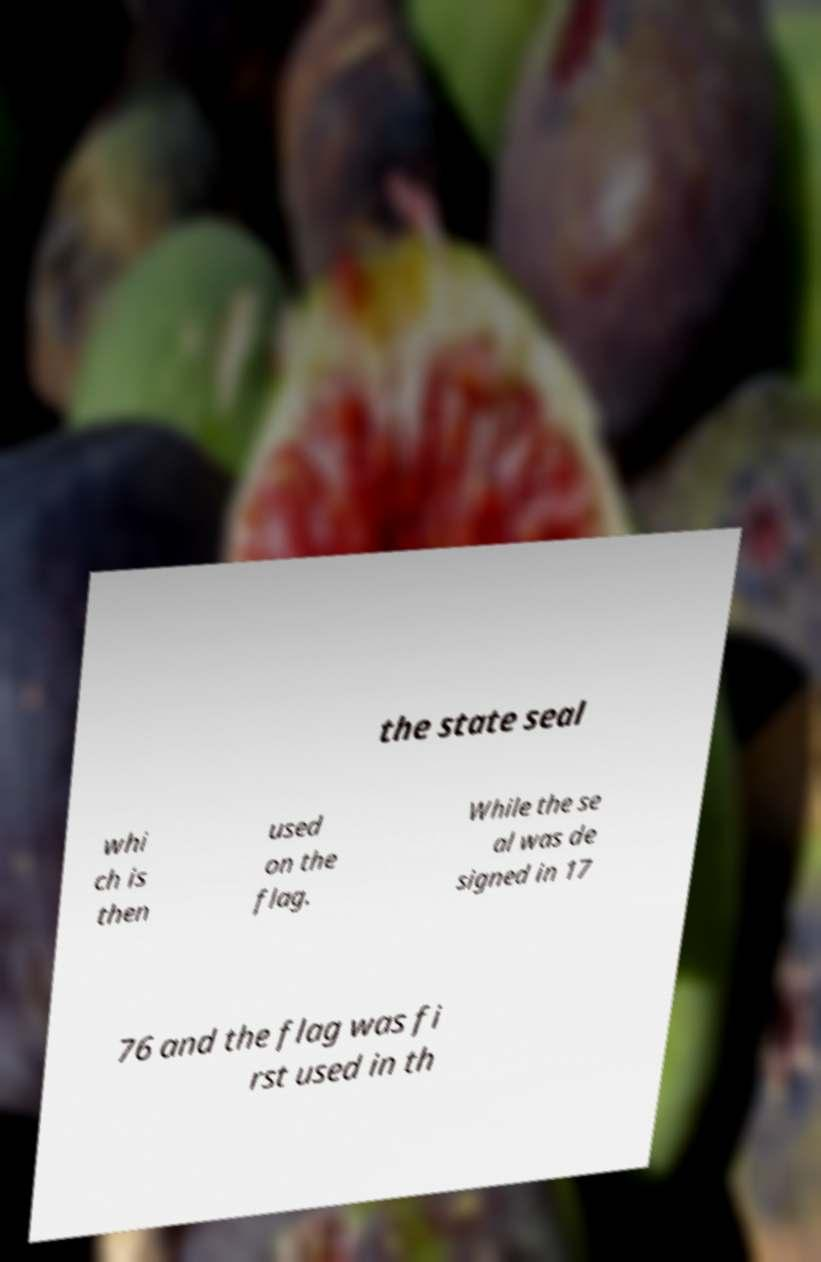Can you accurately transcribe the text from the provided image for me? the state seal whi ch is then used on the flag. While the se al was de signed in 17 76 and the flag was fi rst used in th 